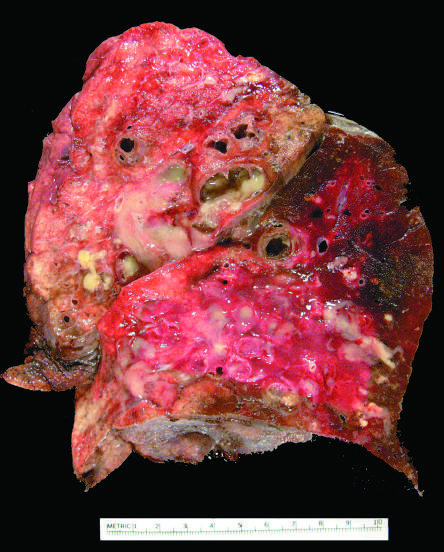does the cut surface of lung show markedly dilated bronchi filled with purulent mucus that extend to subpleural regions?
Answer the question using a single word or phrase. Yes 